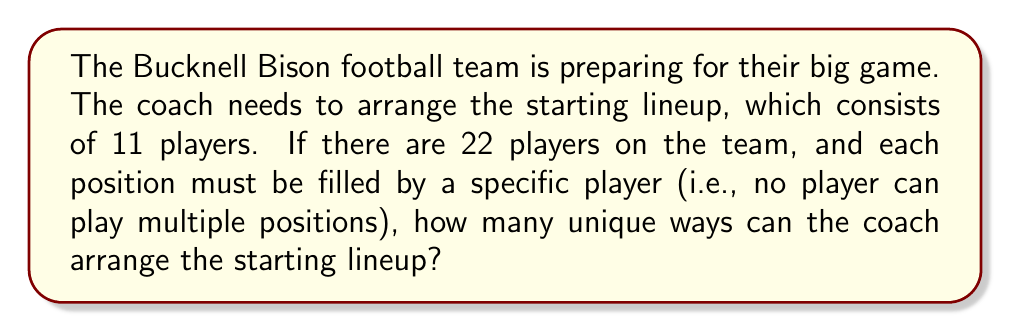Solve this math problem. To solve this problem, we need to use the concept of permutations from Abstract Algebra. Here's how we can approach it:

1) We have 22 players in total, and we need to choose 11 of them for the starting lineup.

2) For the first position, we have 22 choices.

3) For the second position, we have 21 choices (because one player has already been selected).

4) For the third position, we have 20 choices, and so on.

5) This continues until we've selected all 11 players for the starting lineup.

6) Mathematically, this can be represented as:

   $$22 \cdot 21 \cdot 20 \cdot 19 \cdot 18 \cdot 17 \cdot 16 \cdot 15 \cdot 14 \cdot 13 \cdot 12$$

7) This is a permutation, often written as $P(22,11)$ or $_{22}P_{11}$.

8) The formula for this permutation is:

   $$P(22,11) = \frac{22!}{(22-11)!} = \frac{22!}{11!}$$

9) Calculating this:
   
   $$\frac{22!}{11!} = 22 \cdot 21 \cdot 20 \cdot 19 \cdot 18 \cdot 17 \cdot 16 \cdot 15 \cdot 14 \cdot 13 \cdot 12 = 705,432,000$$

Therefore, there are 705,432,000 unique ways to arrange the starting lineup.
Answer: 705,432,000 